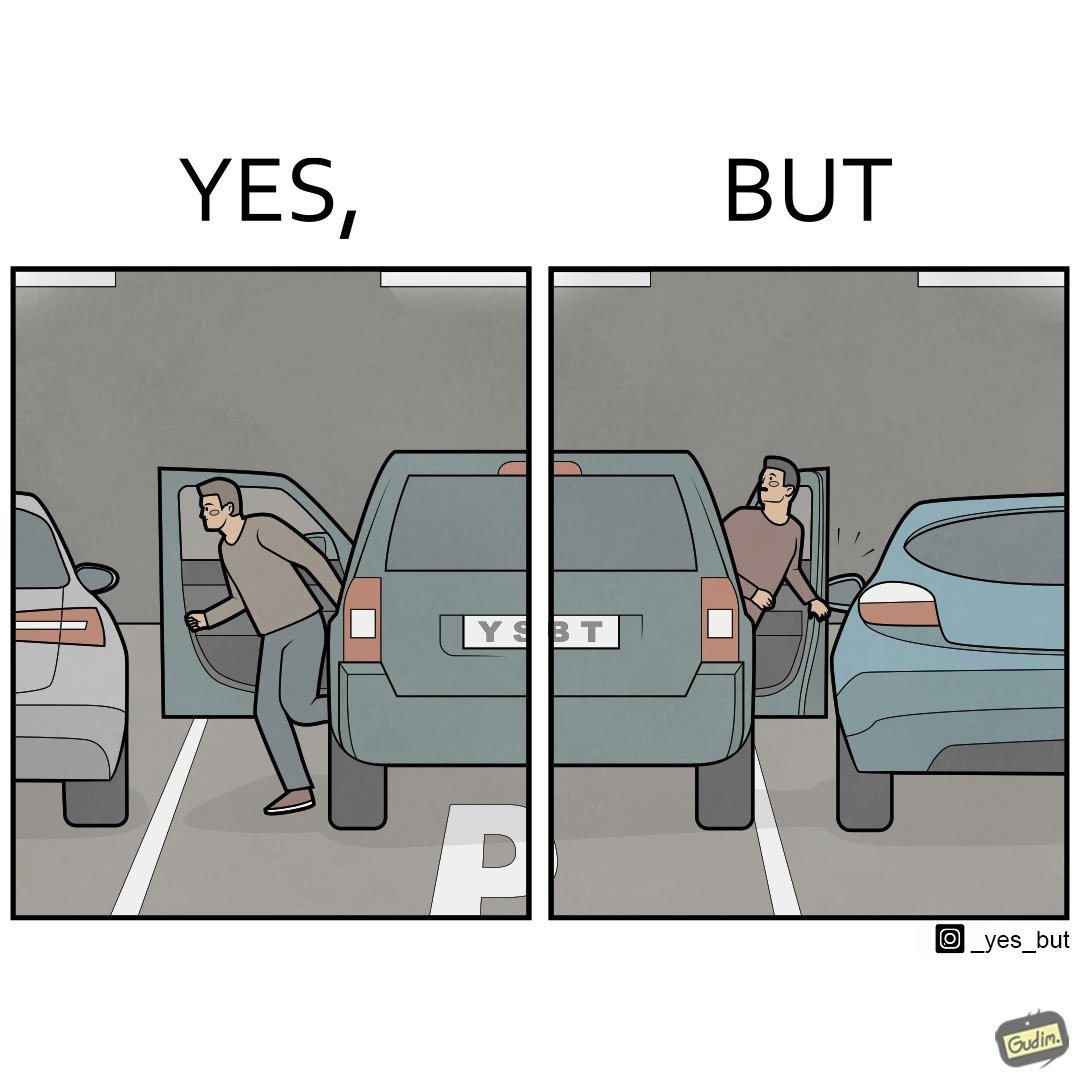Describe what you see in the left and right parts of this image. In the left part of the image: a car at a parking lot and a person is seen getting out of the car In the right part of the image: a car at a parking lot and a person is seen getting out of the car, but the car's doors are touching the neighborhood car, causing inconvenience due to compact space and maybe putting dents on the neighboring car 